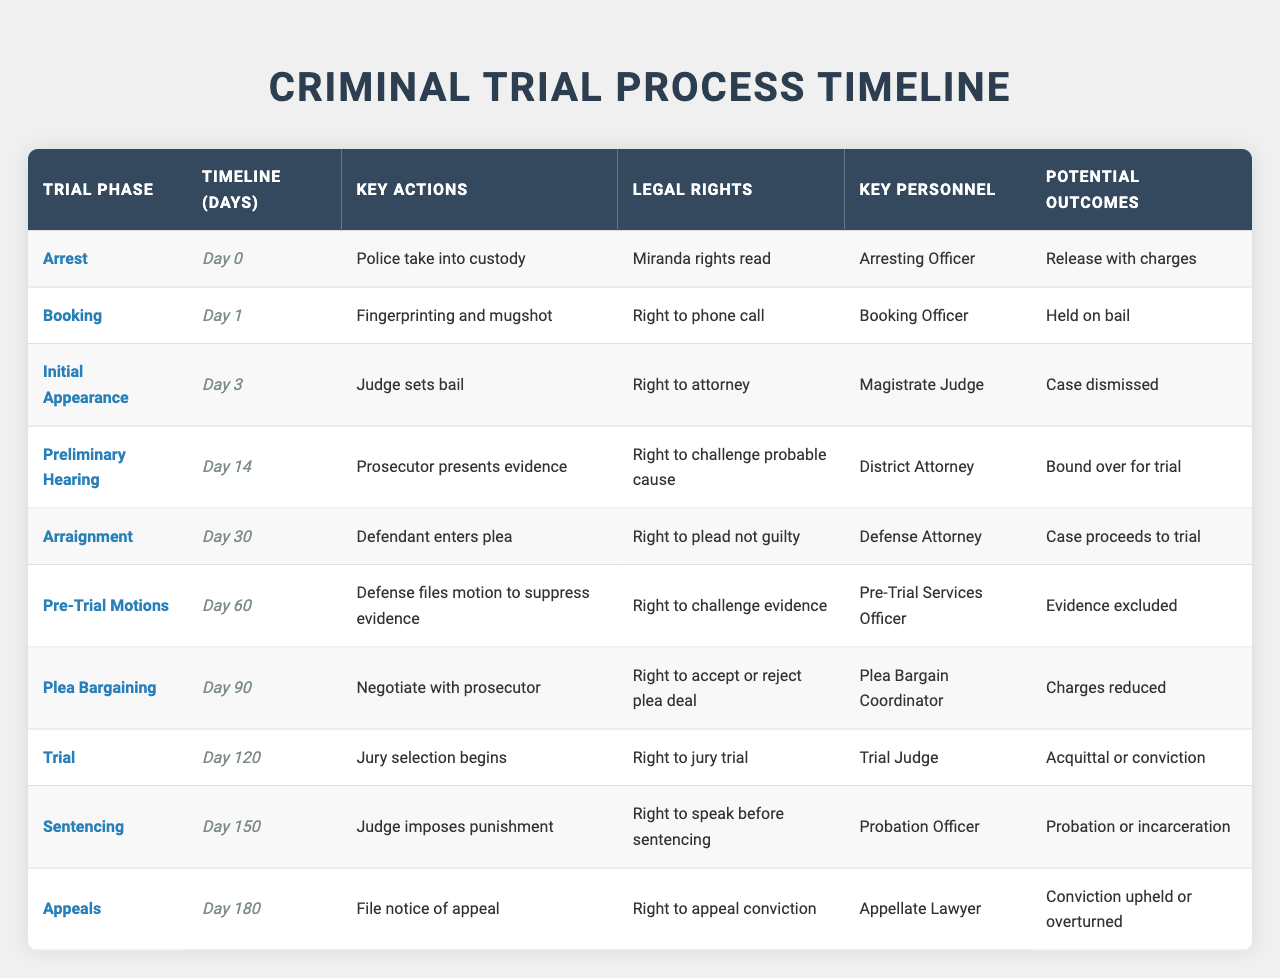What is the key action taken during the 'Initial Appearance'? The table indicates that the key action during the 'Initial Appearance' is that the judge sets bail.
Answer: The judge sets bail How many days after the arrest does the arraignment occur? The arraignment occurs 30 days after the arrest, as indicated in the timeline where 'Arraignment' is listed with a timeline of 30 days.
Answer: 30 days Is the district attorney involved during the plea bargaining phase? Yes, the district attorney is listed as the key personnel during the plea bargaining phase, according to the table.
Answer: Yes What are the legal rights associated with the 'Pre-Trial Motions' phase? The legal rights associated with the 'Pre-Trial Motions' phase include the right to challenge evidence, according to the information in the table.
Answer: Right to challenge evidence Which phase has the potential outcome of "Case dismissed"? The phase with the potential outcome of "Case dismissed" is the 'Preliminary Hearing', as it is noted in the corresponding outcomes in the table.
Answer: Preliminary Hearing How many total days does it take from arrest to sentencing? The total number of days from arrest to sentencing is 150 days, which is calculated as the timeline for 'Sentencing' minus the timeline for 'Arrest' (150 - 0 = 150).
Answer: 150 days In which phase is the defendant's right to plead not guilty acknowledged? The right to plead not guilty is acknowledged during the 'Arraignment' phase as per the legal rights listed in the table.
Answer: Arraignment What is the key personnel involved during the trial phase? The key personnel involved during the trial phase is the trial judge, based on the information in the table.
Answer: Trial Judge Which phase has the right to accept or reject a plea deal? The phase that provides the right to accept or reject a plea deal is the 'Plea Bargaining' phase, as specified in the rights section of the table.
Answer: Plea Bargaining What is the difference in days between the arraignment and the preliminary hearing phases? The difference in days between the arraignment (30 days) and the preliminary hearing (14 days) is 16 days (30 - 14 = 16).
Answer: 16 days 